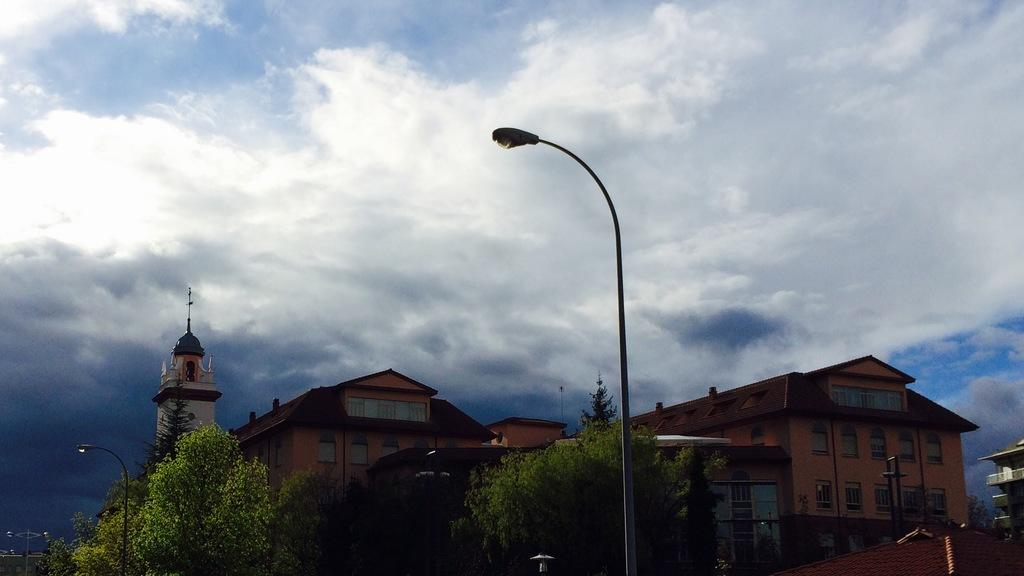What structures are present in the image? There are poles, trees, and buildings in the image. Can you describe the natural elements in the image? There are trees in the image. What is the condition of the sky in the image? The sky is cloudy in the image. Can you tell me how many cents the doctor is charging for the wilderness in the image? There is no mention of a doctor, cents, or wilderness in the image. The image features poles, trees, buildings, and a cloudy sky. 